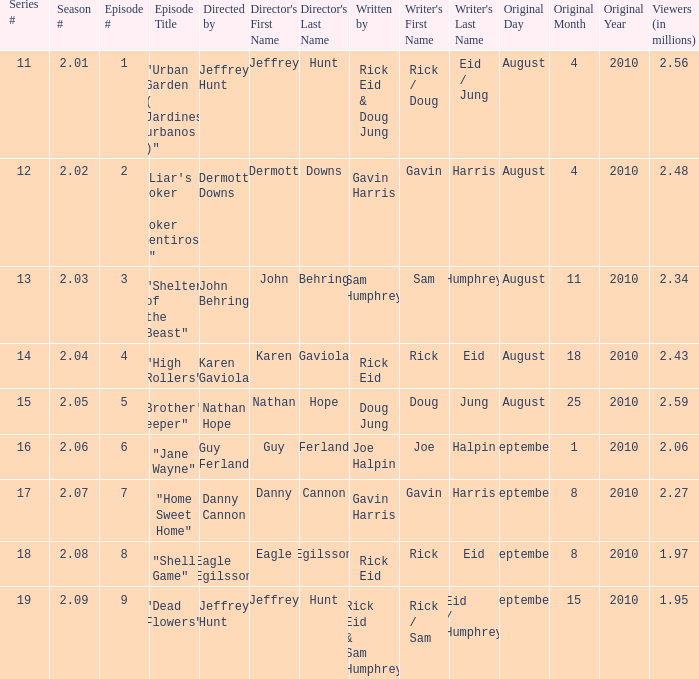If the amount of viewers is 2.48 million, what is the original air date? August4,2010. 